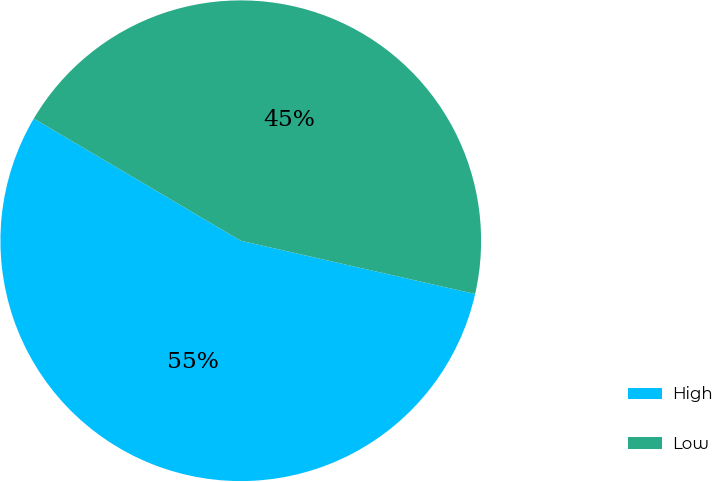Convert chart to OTSL. <chart><loc_0><loc_0><loc_500><loc_500><pie_chart><fcel>High<fcel>Low<nl><fcel>54.93%<fcel>45.07%<nl></chart> 